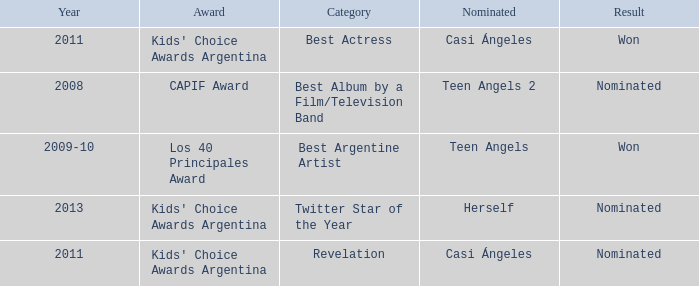For what award was there a nomination for Best Actress? Kids' Choice Awards Argentina. 